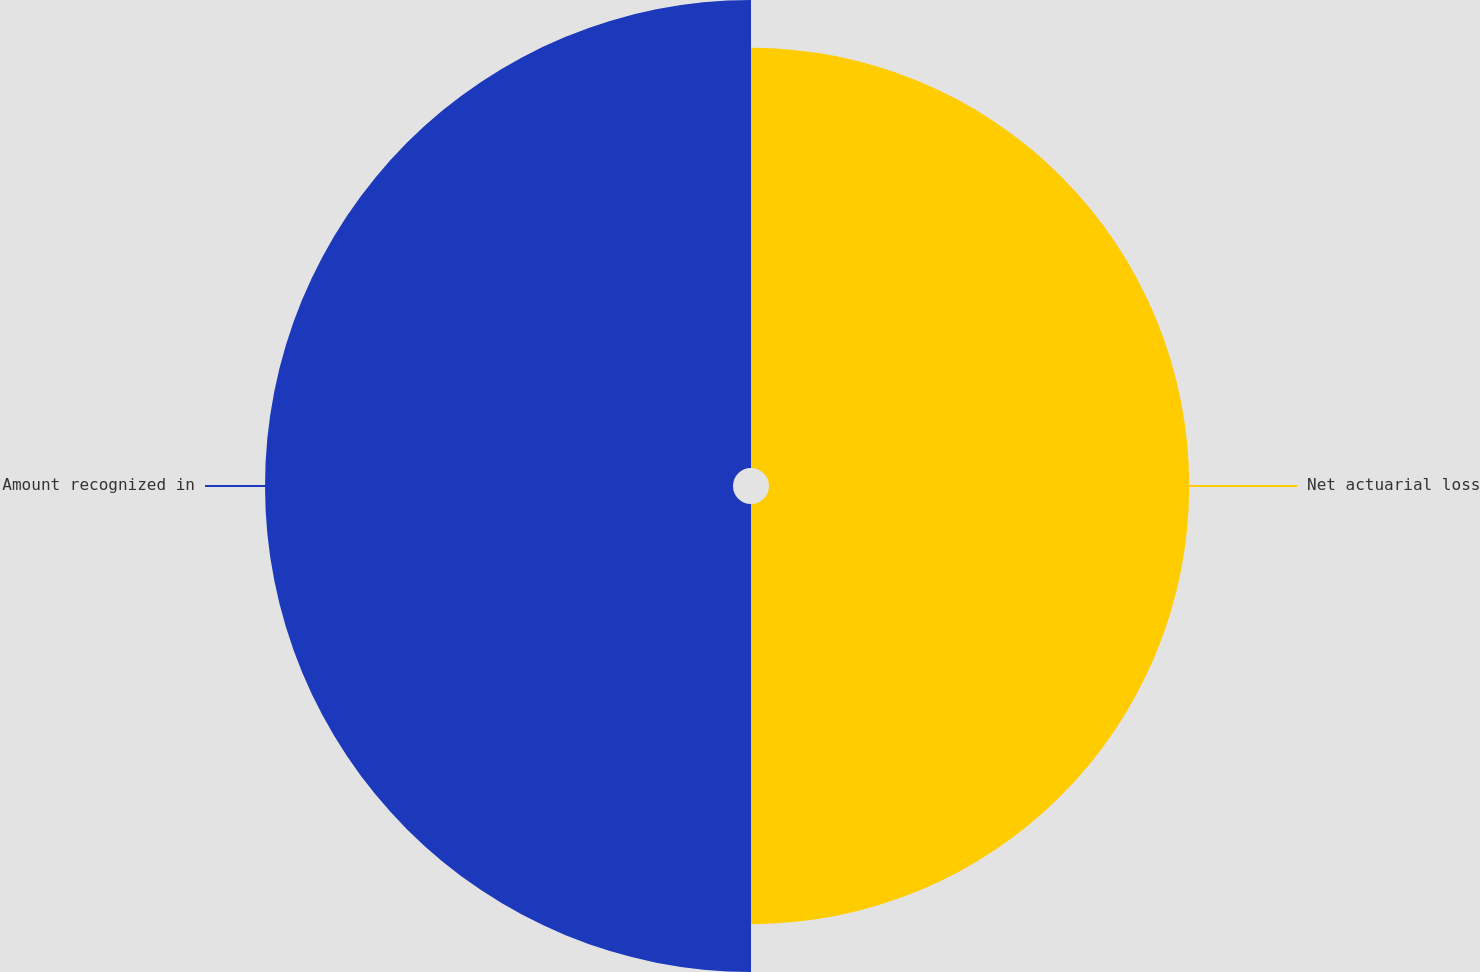<chart> <loc_0><loc_0><loc_500><loc_500><pie_chart><fcel>Net actuarial loss<fcel>Amount recognized in<nl><fcel>47.31%<fcel>52.69%<nl></chart> 